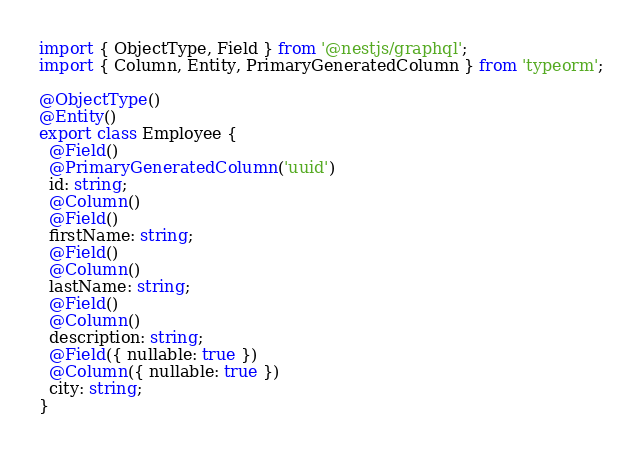Convert code to text. <code><loc_0><loc_0><loc_500><loc_500><_TypeScript_>import { ObjectType, Field } from '@nestjs/graphql';
import { Column, Entity, PrimaryGeneratedColumn } from 'typeorm';

@ObjectType()
@Entity()
export class Employee {
  @Field()
  @PrimaryGeneratedColumn('uuid')
  id: string;
  @Column()
  @Field()
  firstName: string;
  @Field()
  @Column()
  lastName: string;
  @Field()
  @Column()
  description: string;
  @Field({ nullable: true })
  @Column({ nullable: true })
  city: string;
}
</code> 